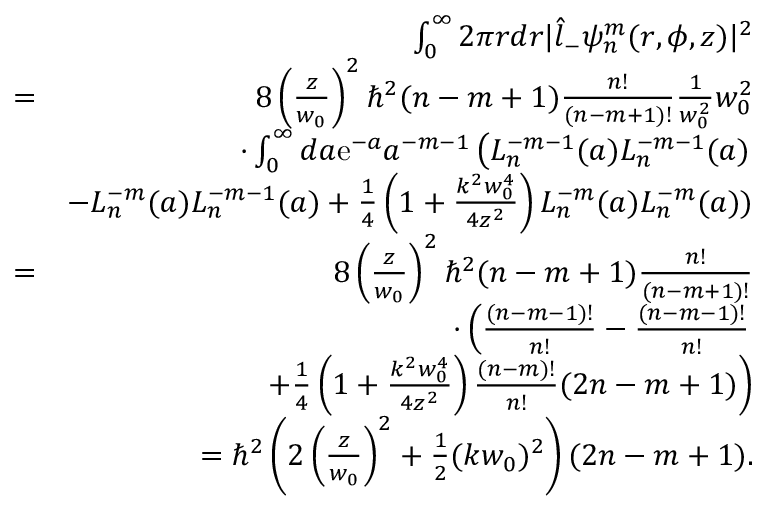Convert formula to latex. <formula><loc_0><loc_0><loc_500><loc_500>\begin{array} { r l r } & { \int _ { 0 } ^ { \infty } 2 \pi r d r | \hat { l } _ { - } \psi _ { n } ^ { m } ( r , \phi , z ) | ^ { 2 } } \\ & { = } & { 8 \left ( \frac { z } { w _ { 0 } } \right ) ^ { 2 } \hbar { ^ } { 2 } ( n - m + 1 ) \frac { n ! } { ( n - m + 1 ) ! } \frac { 1 } { w _ { 0 } ^ { 2 } } w _ { 0 } ^ { 2 } } \\ & { \cdot \int _ { 0 } ^ { \infty } d a e ^ { - a } a ^ { - m - 1 } \left ( L _ { n } ^ { - m - 1 } ( a ) L _ { n } ^ { - m - 1 } ( a ) } \\ & { - L _ { n } ^ { - m } ( a ) L _ { n } ^ { - m - 1 } ( a ) + \frac { 1 } { 4 } \left ( 1 + \frac { k ^ { 2 } w _ { 0 } ^ { 4 } } { 4 z ^ { 2 } } \right ) L _ { n } ^ { - m } ( a ) L _ { n } ^ { - m } ( a ) ) } \\ & { = } & { 8 \left ( \frac { z } { w _ { 0 } } \right ) ^ { 2 } \hbar { ^ } { 2 } ( n - m + 1 ) \frac { n ! } { ( n - m + 1 ) ! } } \\ & { \cdot \left ( \frac { ( n - m - 1 ) ! } { n ! } - \frac { ( n - m - 1 ) ! } { n ! } } \\ & { + \frac { 1 } { 4 } \left ( 1 + \frac { k ^ { 2 } w _ { 0 } ^ { 4 } } { 4 z ^ { 2 } } \right ) \frac { ( n - m ) ! } { n ! } ( 2 n - m + 1 ) \right ) } \\ & { = \hbar { ^ } { 2 } \left ( 2 \left ( \frac { z } { w _ { 0 } } \right ) ^ { 2 } + \frac { 1 } { 2 } ( k w _ { 0 } ) ^ { 2 } \right ) ( 2 n - m + 1 ) . } \end{array}</formula> 